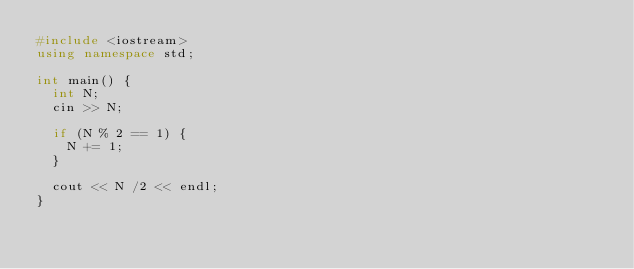Convert code to text. <code><loc_0><loc_0><loc_500><loc_500><_C++_>#include <iostream>
using namespace std;

int main() {
  int N;
  cin >> N;

  if (N % 2 == 1) {
    N += 1;
  }

  cout << N /2 << endl;
}
</code> 